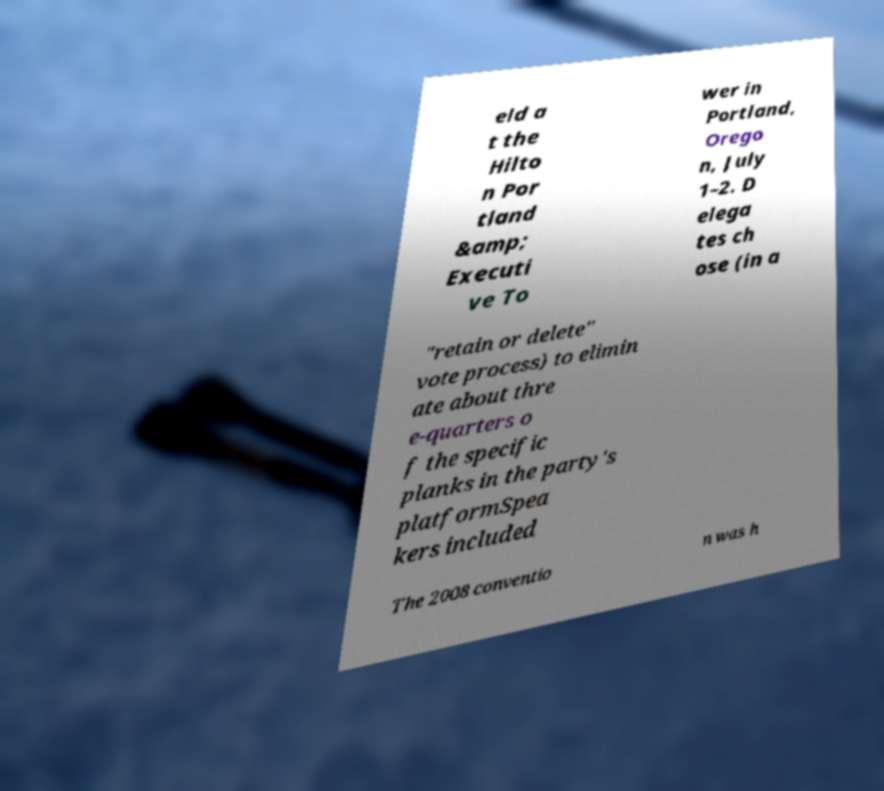For documentation purposes, I need the text within this image transcribed. Could you provide that? eld a t the Hilto n Por tland &amp; Executi ve To wer in Portland, Orego n, July 1–2. D elega tes ch ose (in a "retain or delete" vote process) to elimin ate about thre e-quarters o f the specific planks in the party's platformSpea kers included The 2008 conventio n was h 